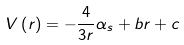<formula> <loc_0><loc_0><loc_500><loc_500>V \left ( r \right ) = - \frac { 4 } { 3 r } \alpha _ { s } + b r + c</formula> 